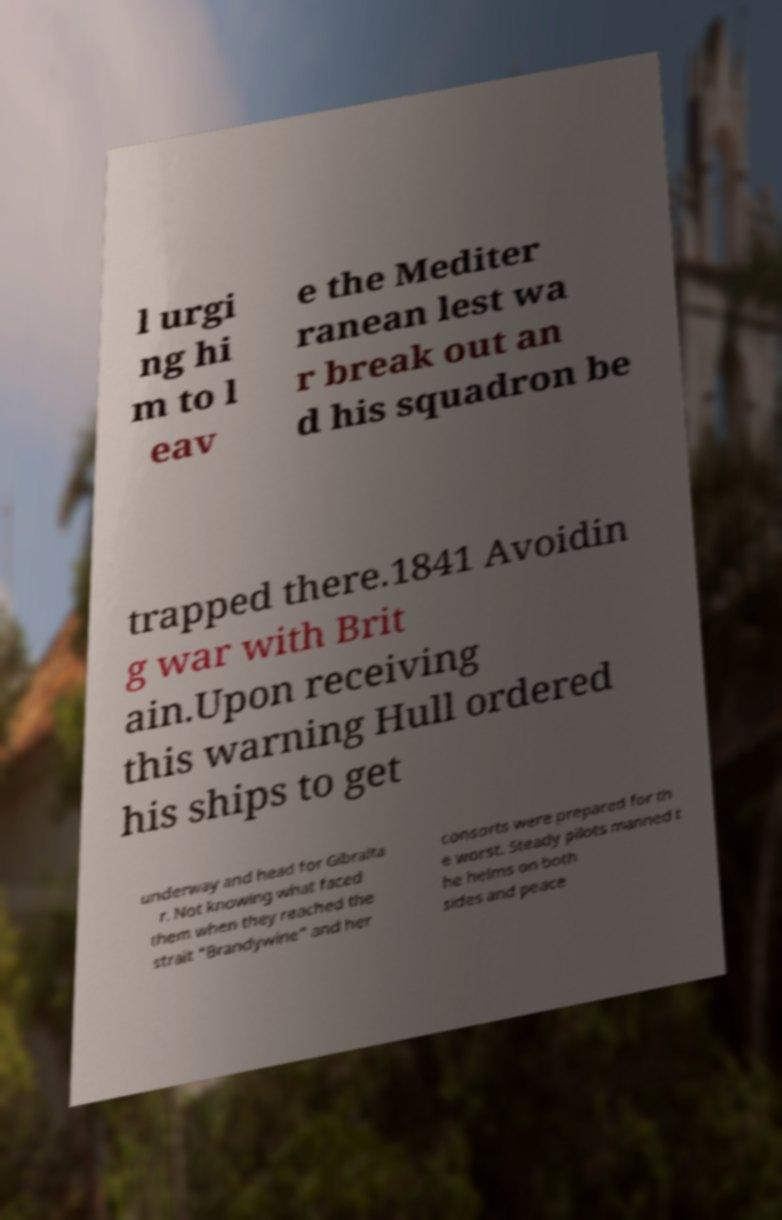What messages or text are displayed in this image? I need them in a readable, typed format. l urgi ng hi m to l eav e the Mediter ranean lest wa r break out an d his squadron be trapped there.1841 Avoidin g war with Brit ain.Upon receiving this warning Hull ordered his ships to get underway and head for Gibralta r. Not knowing what faced them when they reached the strait "Brandywine" and her consorts were prepared for th e worst. Steady pilots manned t he helms on both sides and peace 